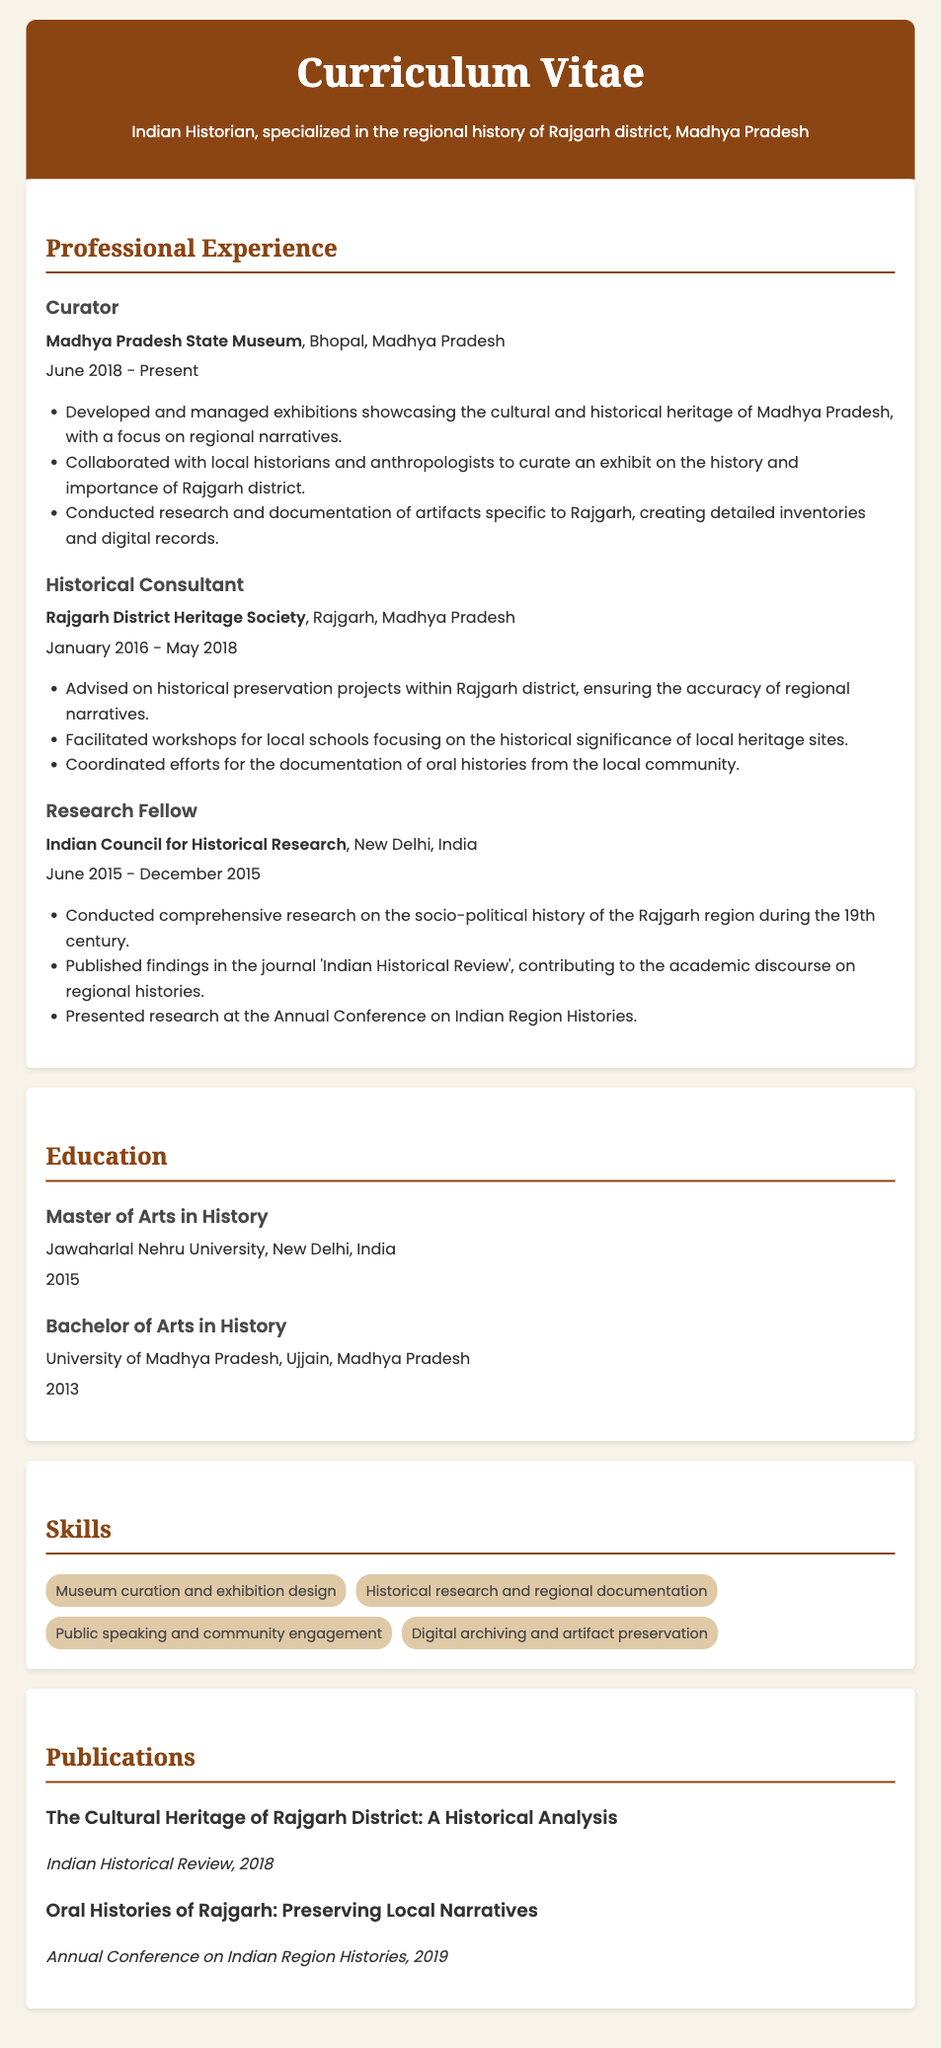what is the current position held by the historian? The document states the current job title of the historian as "Curator" at Madhya Pradesh State Museum.
Answer: Curator where did the historian obtain their Master's degree? The Master's degree was obtained at Jawaharlal Nehru University, as mentioned in the education section of the document.
Answer: Jawaharlal Nehru University how long did they work at the Rajgarh District Heritage Society? The historian worked at the Rajgarh District Heritage Society from January 2016 to May 2018, which totals around 2 years and 4 months.
Answer: 2 years and 4 months what is one publication authored by the historian? The document lists "The Cultural Heritage of Rajgarh District: A Historical Analysis" as one of the publications, providing specific information on their work.
Answer: The Cultural Heritage of Rajgarh District: A Historical Analysis which historical theme did the Research Fellow focus on? As a Research Fellow, the historian focused on the socio-political history of the Rajgarh region during the 19th century, as noted in their experience.
Answer: socio-political history of the Rajgarh region during the 19th century what year did the historian complete their Bachelor of Arts? The Bachelor of Arts in History was completed in 2013, as indicated in the education section.
Answer: 2013 what organization did the curator collaborate with for the Rajgarh exhibit? The curator collaborated with local historians and anthropologists to curate an exhibit on Rajgarh, showing a direct teamwork aspect of the role.
Answer: local historians and anthropologists how many key skills are listed in the CV? The skills section enumerates four specific skills the historian possesses, showcasing their capabilities in the field.
Answer: Four which journal published the historian's findings on the Rajgarh region? The findings of the Research Fellow were published in the "Indian Historical Review," providing a source for their research contributions.
Answer: Indian Historical Review 